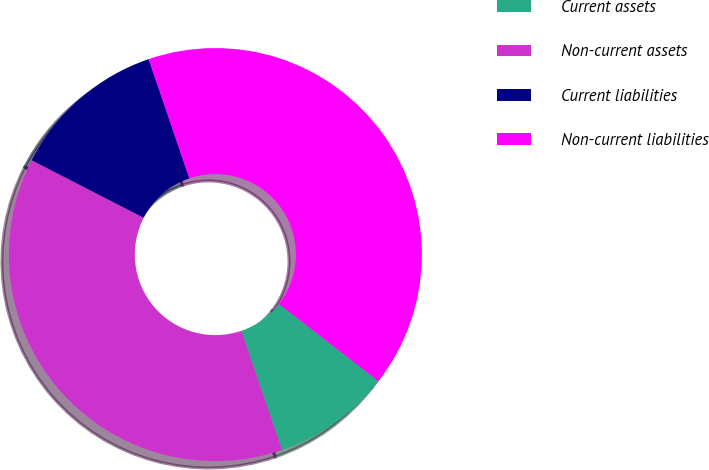Convert chart. <chart><loc_0><loc_0><loc_500><loc_500><pie_chart><fcel>Current assets<fcel>Non-current assets<fcel>Current liabilities<fcel>Non-current liabilities<nl><fcel>9.26%<fcel>37.79%<fcel>12.21%<fcel>40.74%<nl></chart> 